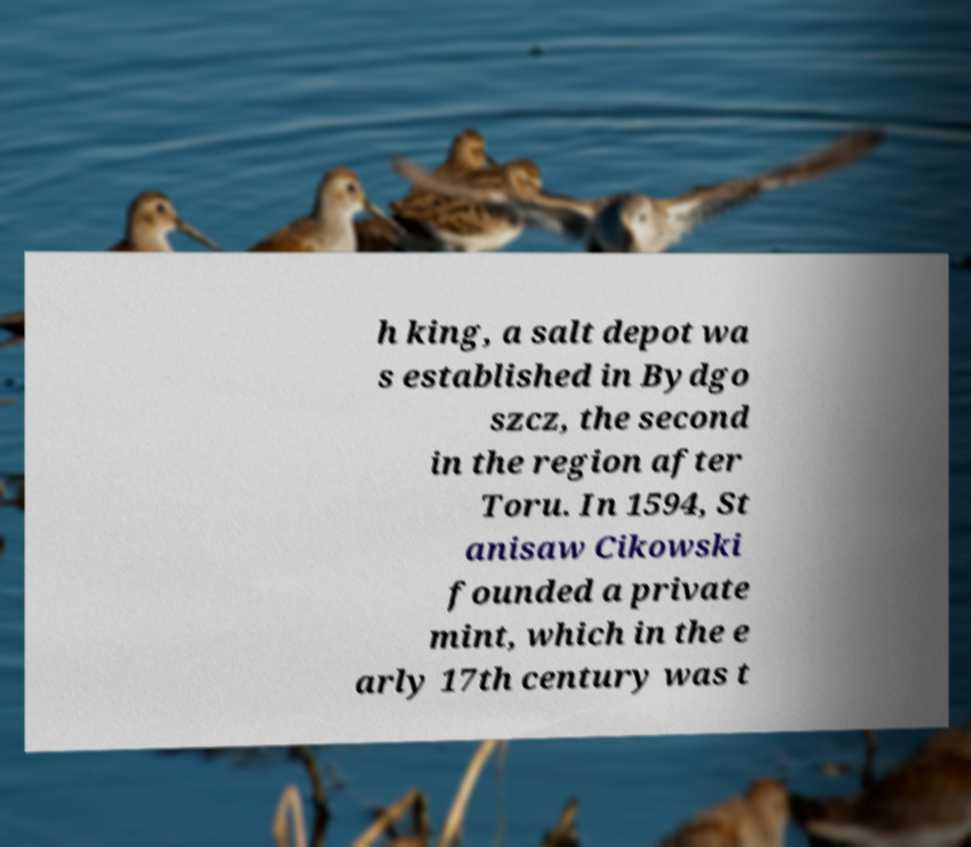Could you extract and type out the text from this image? h king, a salt depot wa s established in Bydgo szcz, the second in the region after Toru. In 1594, St anisaw Cikowski founded a private mint, which in the e arly 17th century was t 